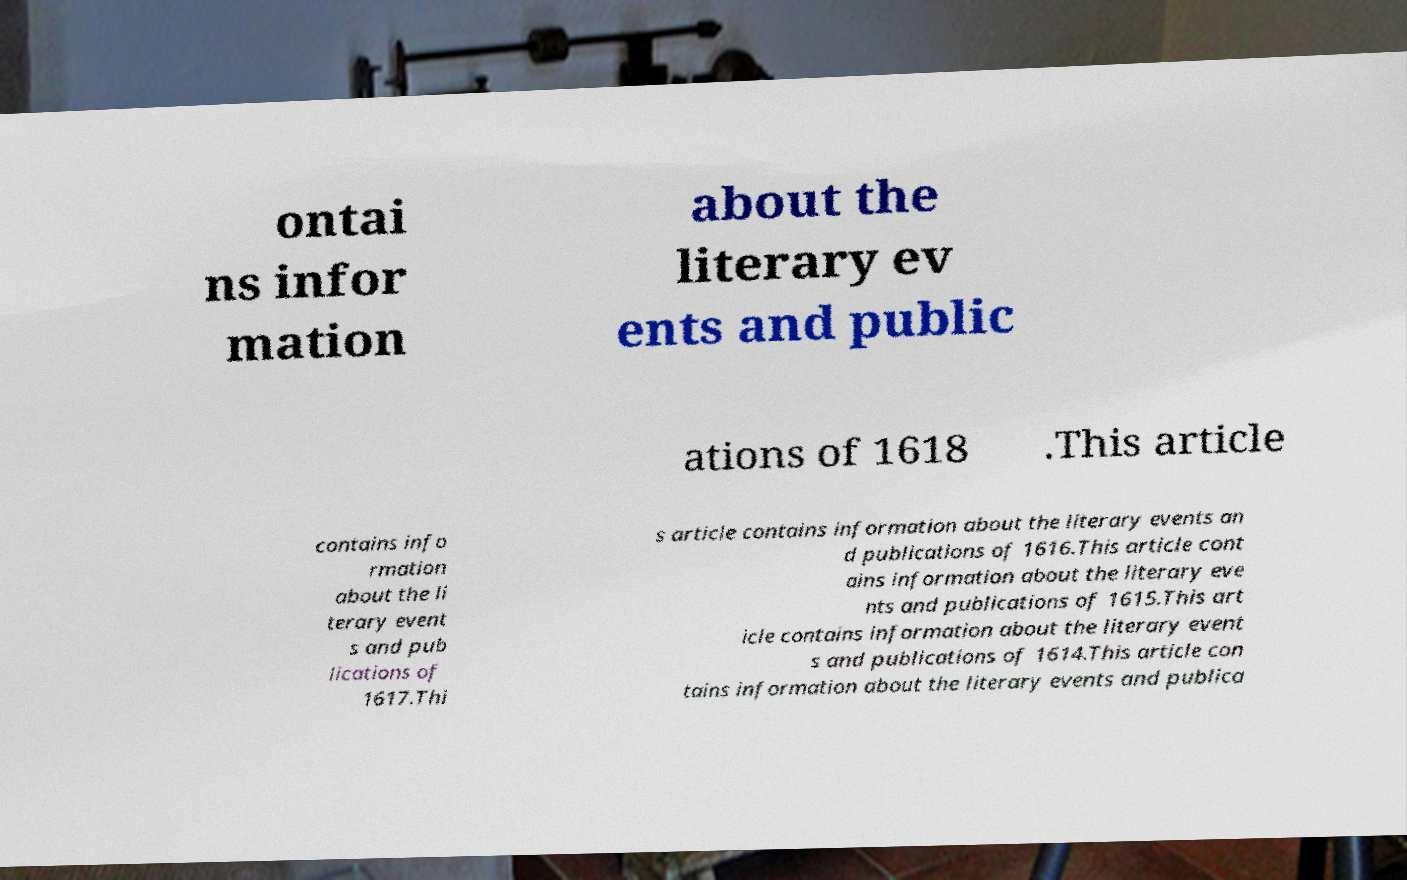I need the written content from this picture converted into text. Can you do that? ontai ns infor mation about the literary ev ents and public ations of 1618 .This article contains info rmation about the li terary event s and pub lications of 1617.Thi s article contains information about the literary events an d publications of 1616.This article cont ains information about the literary eve nts and publications of 1615.This art icle contains information about the literary event s and publications of 1614.This article con tains information about the literary events and publica 